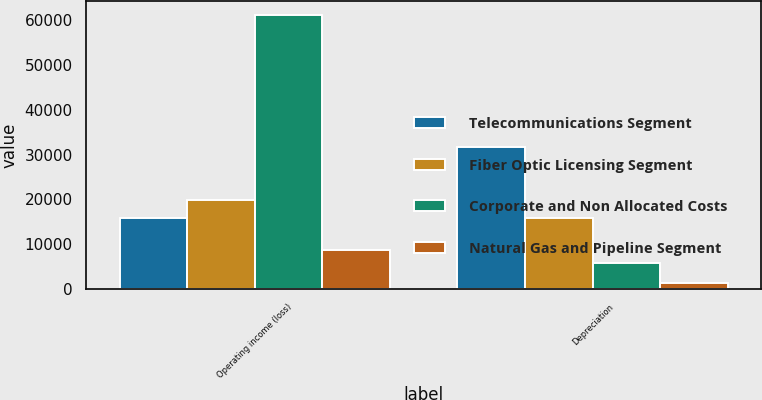Convert chart to OTSL. <chart><loc_0><loc_0><loc_500><loc_500><stacked_bar_chart><ecel><fcel>Operating income (loss)<fcel>Depreciation<nl><fcel>Telecommunications Segment<fcel>15766<fcel>31664<nl><fcel>Fiber Optic Licensing Segment<fcel>19965<fcel>15766<nl><fcel>Corporate and Non Allocated Costs<fcel>61158<fcel>5868<nl><fcel>Natural Gas and Pipeline Segment<fcel>8714<fcel>1450<nl></chart> 